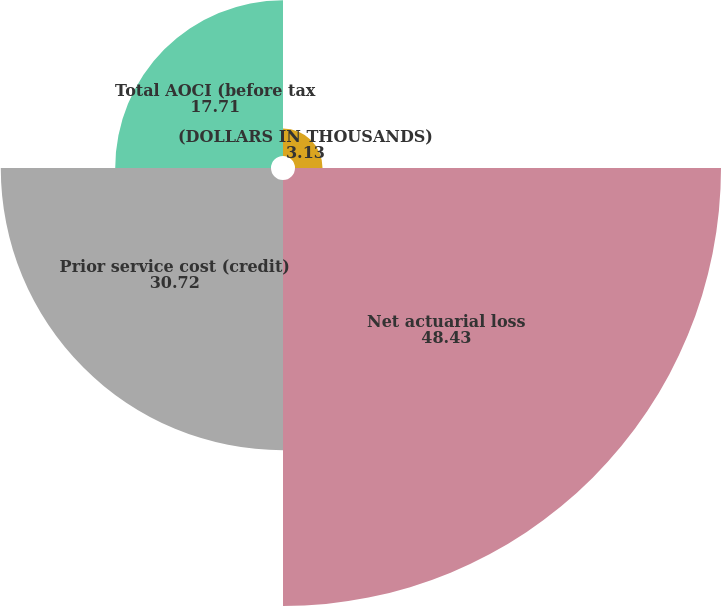Convert chart. <chart><loc_0><loc_0><loc_500><loc_500><pie_chart><fcel>(DOLLARS IN THOUSANDS)<fcel>Net actuarial loss<fcel>Prior service cost (credit)<fcel>Total AOCI (before tax<nl><fcel>3.13%<fcel>48.43%<fcel>30.72%<fcel>17.71%<nl></chart> 